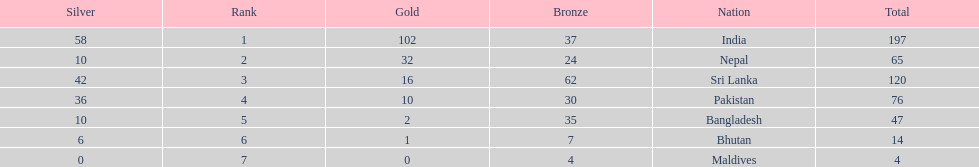What is the difference between the nation with the most medals and the nation with the least amount of medals? 193. 